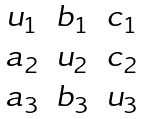<formula> <loc_0><loc_0><loc_500><loc_500>\begin{matrix} u _ { 1 } & b _ { 1 } & c _ { 1 } \\ a _ { 2 } & u _ { 2 } & c _ { 2 } \\ a _ { 3 } & b _ { 3 } & u _ { 3 } \end{matrix}</formula> 